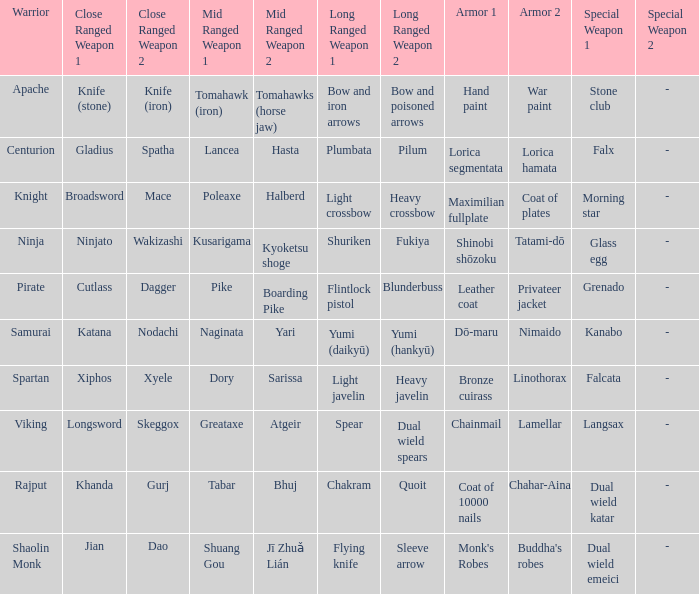If the Close ranged weapons are the knife (stone), knife (iron), what are the Long ranged weapons? Bow and iron arrows, Bow and poisoned arrows. 